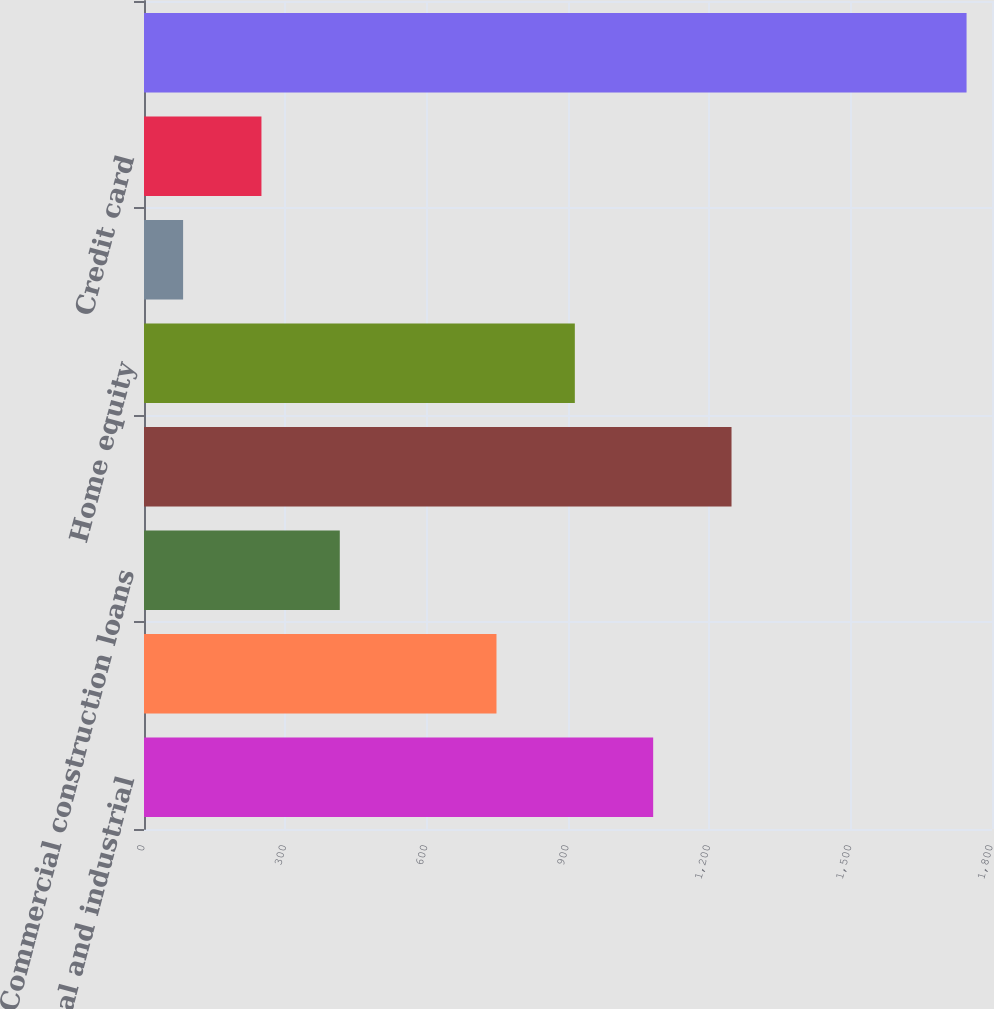Convert chart to OTSL. <chart><loc_0><loc_0><loc_500><loc_500><bar_chart><fcel>Commercial and industrial<fcel>Commercial mortgage<fcel>Commercial construction loans<fcel>Residential mortgage loans<fcel>Home equity<fcel>Automobile loans<fcel>Credit card<fcel>Total portfolio loans and<nl><fcel>1080.8<fcel>748.2<fcel>415.6<fcel>1247.1<fcel>914.5<fcel>83<fcel>249.3<fcel>1746<nl></chart> 